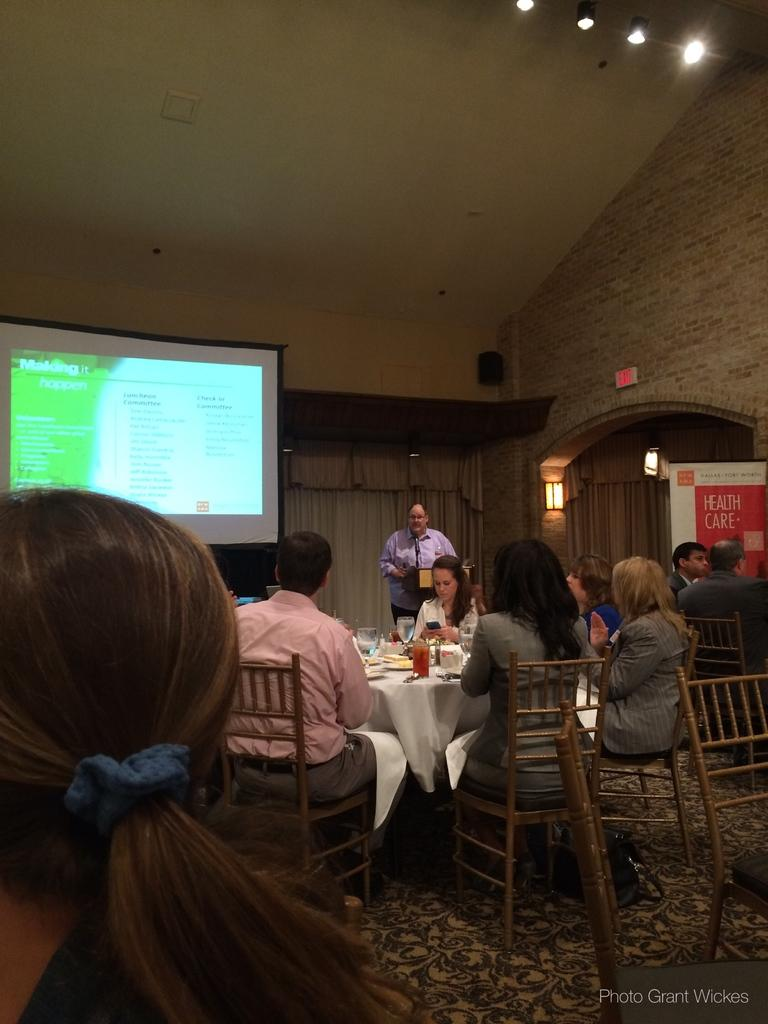What are the people in the image doing? There is a group of people sitting on chairs in the image. What objects can be seen on the table in the image? There are glasses and plates on a table in the image. What is visible at the top of the image? There is a screen visible at the top of the image. What can be used to provide illumination in the image? There is a light visible in the image. What type of cart is visible in the image? There is no cart present in the image. What angle is the front of the room captured from in the image? The image does not provide information about the angle or perspective from which it was taken. 